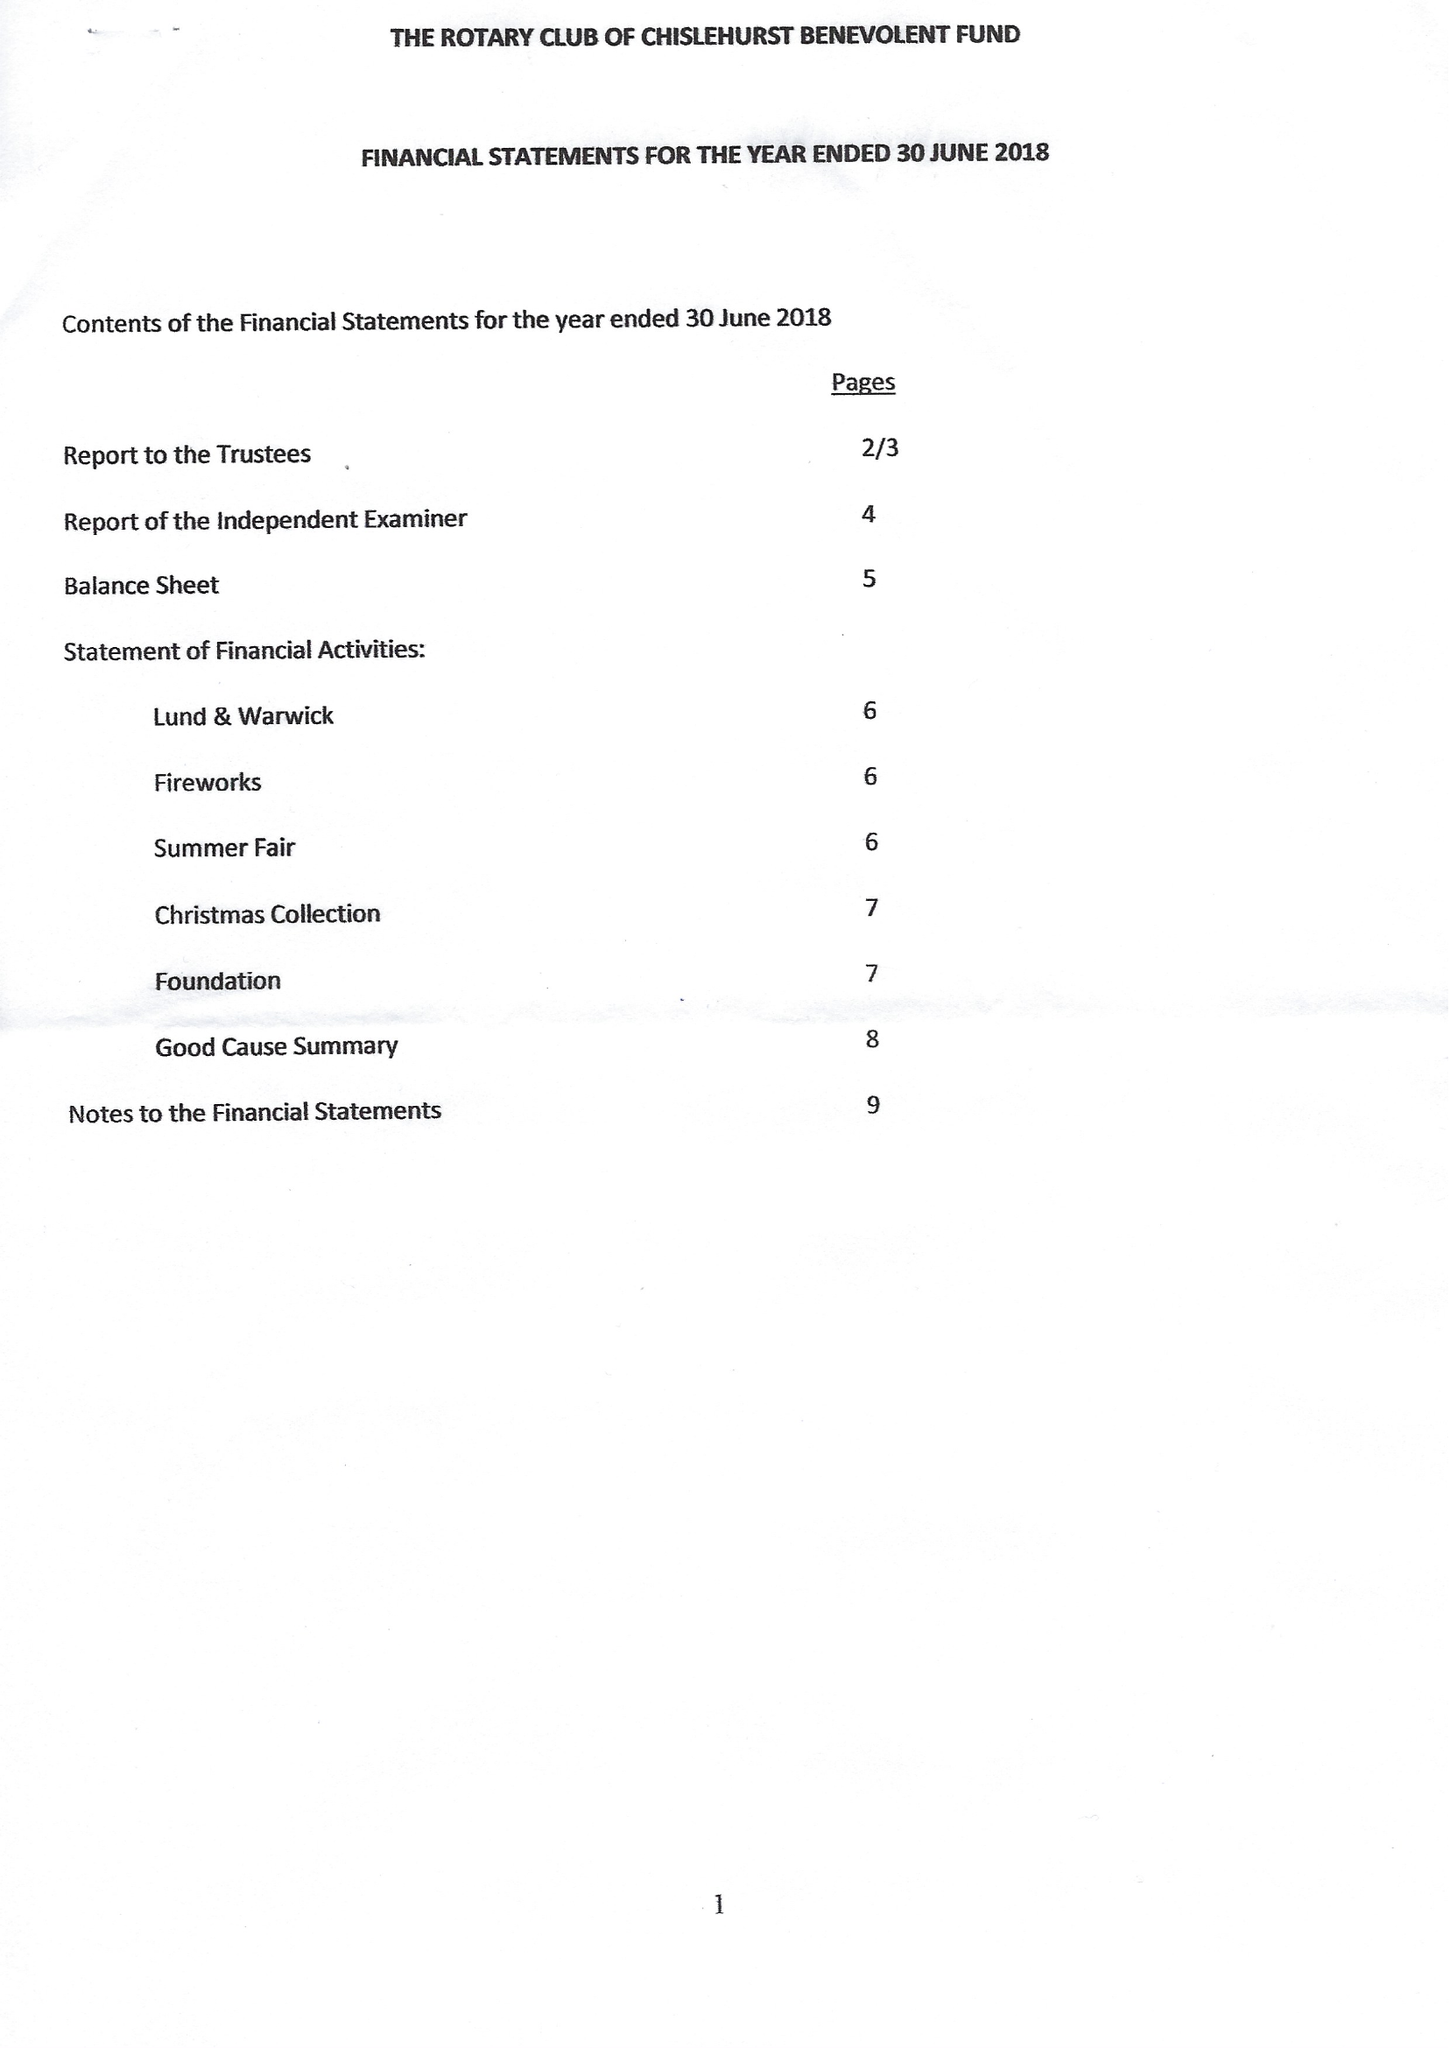What is the value for the spending_annually_in_british_pounds?
Answer the question using a single word or phrase. 33232.00 